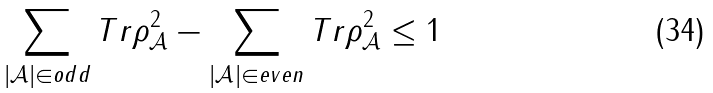Convert formula to latex. <formula><loc_0><loc_0><loc_500><loc_500>\sum _ { | \mathcal { A } | \in o d d } T r \rho _ { \mathcal { A } } ^ { 2 } - \sum _ { | \mathcal { A } | \in e v e n } T r \rho _ { \mathcal { A } } ^ { 2 } \leq 1</formula> 